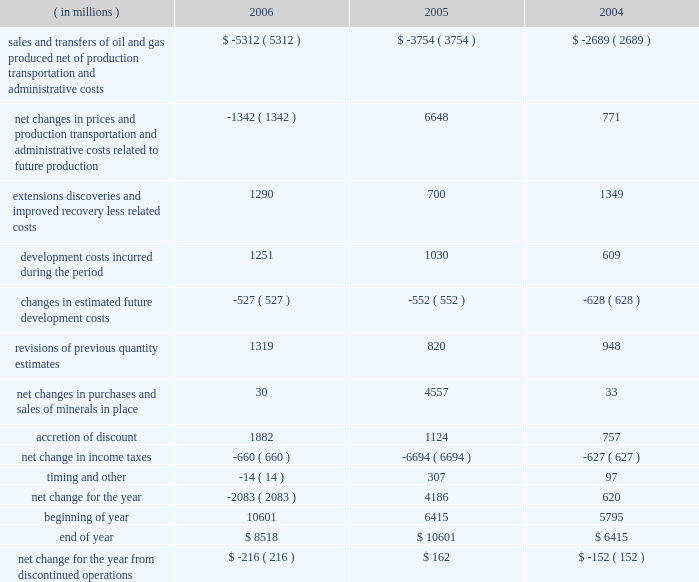Supplementary information on oil and gas producing activities ( unaudited ) c o n t i n u e d summary of changes in standardized measure of discounted future net cash flows relating to proved oil and gas reserves ( in millions ) 2006 2005 2004 sales and transfers of oil and gas produced , net of production , transportation and administrative costs $ ( 5312 ) $ ( 3754 ) $ ( 2689 ) net changes in prices and production , transportation and administrative costs related to future production ( 1342 ) 6648 771 .

What was the average upward revisions of cash flow of previous quantity estimates during the three year period , in millions? 
Computations: table_average(revisions of previous quantity estimates, none)
Answer: 1029.0. 